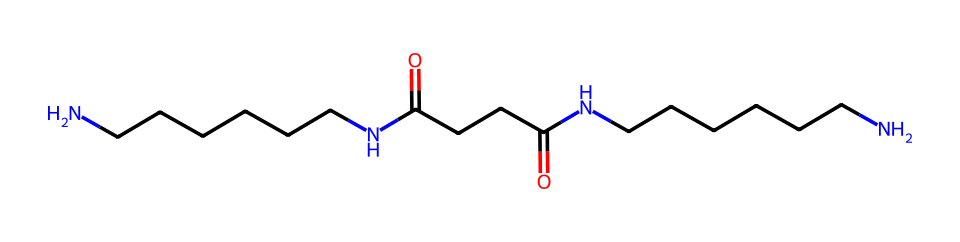What is the main functional group present in this structure? The chemical contains an amide group, indicated by the presence of carbonyl (C=O) directly bonded to a nitrogen atom (N). This is characteristic of amides.
Answer: amide How many nitrogen atoms are present in this structure? By examining the SMILES representation, we can identify that there are two nitrogen (N) atoms in the structure, each part of an amide group.
Answer: 2 What type of polymer is represented by this chemical structure? This structure represents a type of polyamide, which is made through the polymerization of monomers that contain amide linkages.
Answer: polyamide What might be a significant property of nylon fibers used in media production? The polymer structure, especially the presence of strong intermolecular forces due to hydrogen bonding in the amide groups, leads to durability and resistance to wear.
Answer: durability How many total carbon atoms are present in this chemical structure? By carefully counting the carbon (C) atoms represented in the structure, including those in the backbone and functional groups, we find a total of 12 carbon atoms.
Answer: 12 Why are nylon fibers suitable for microphone windscreens? The polymer structure of nylon provides a lightweight and effective barrier that can reduce wind noise while still being breathable, which is critical for sound clarity in media production.
Answer: lightweight 